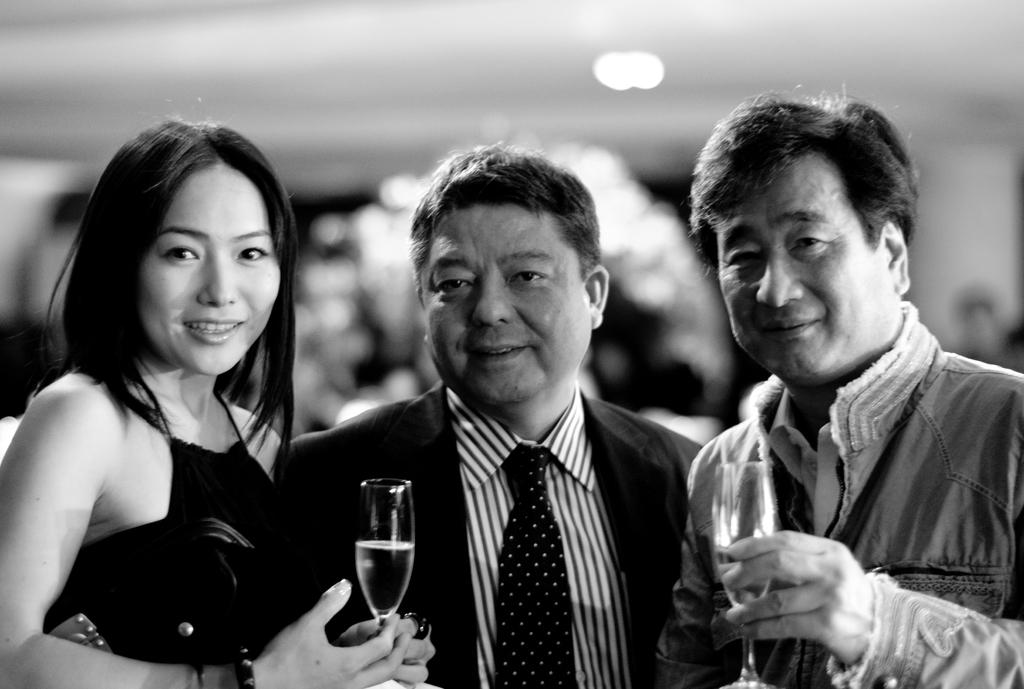How many people are in the image? There are three persons in the image. Can you describe the gender of the people in the image? Two of the persons are men, and one is a woman. What are the people in the image doing? The three persons are standing together. What are the people holding in their hands? Each person is holding a glass with a liquid in their hand. What type of humor can be heard coming from the gate in the image? There is no gate present in the image, and therefore no humor can be heard coming from it. 